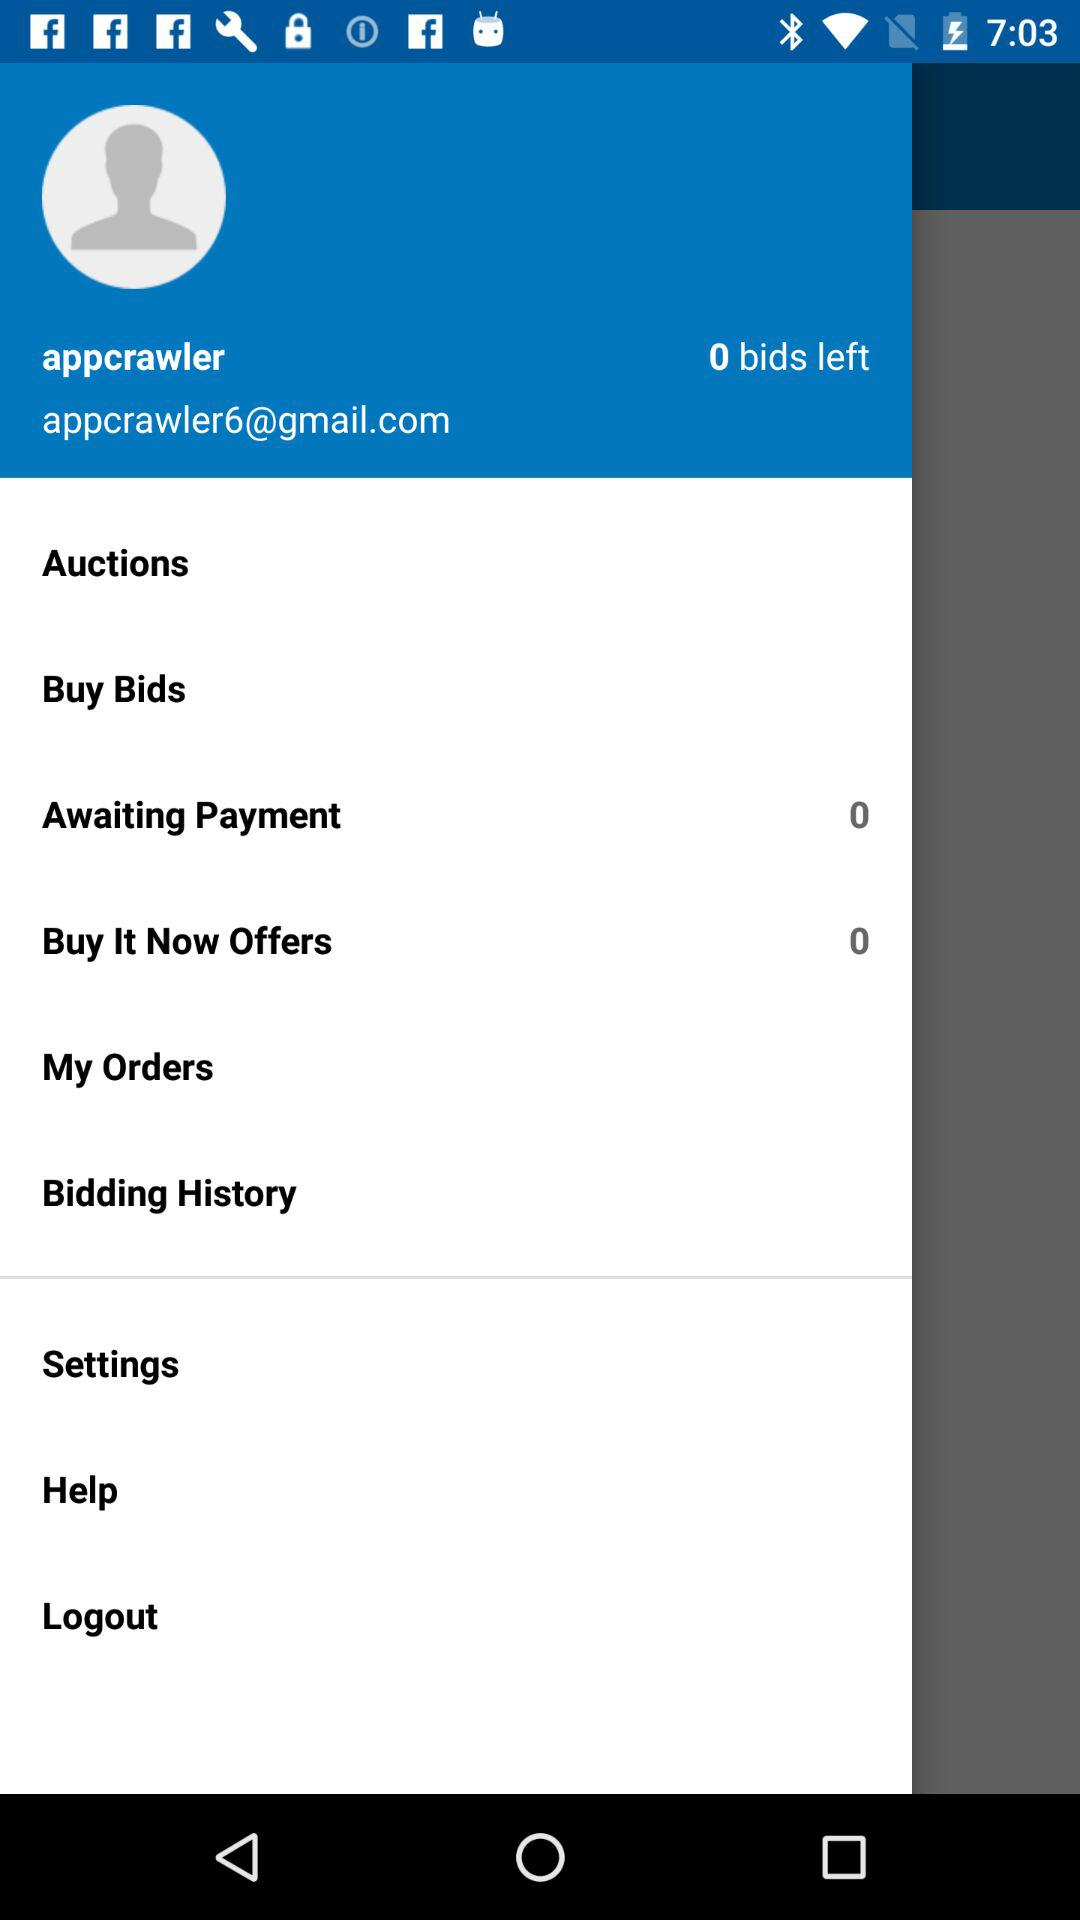How many bids are left? The bids left are 0. 